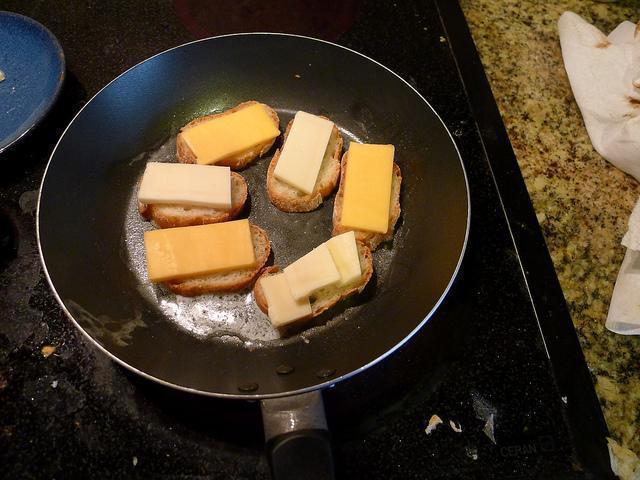What will happen to the yellow and white slices?
Select the correct answer and articulate reasoning with the following format: 'Answer: answer
Rationale: rationale.'
Options: Will evaporate, will burn, get crispy, will melt. Answer: will melt.
Rationale: The yellow and white slices of cheese are on the frying pan and will melt. 